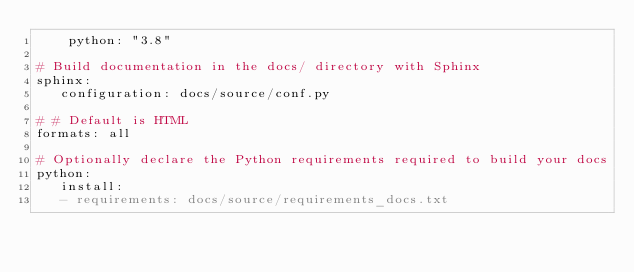<code> <loc_0><loc_0><loc_500><loc_500><_YAML_>    python: "3.8"

# Build documentation in the docs/ directory with Sphinx
sphinx:
   configuration: docs/source/conf.py

# # Default is HTML
formats: all

# Optionally declare the Python requirements required to build your docs
python:
   install:
   - requirements: docs/source/requirements_docs.txt
</code> 